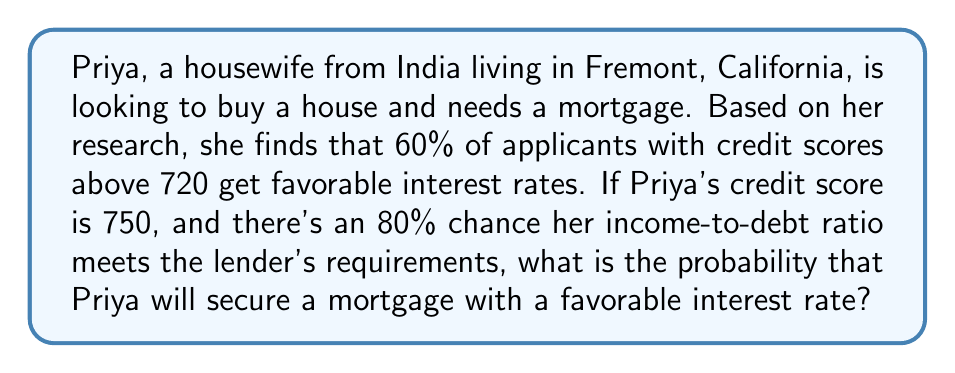Could you help me with this problem? To solve this problem, we need to consider two independent events:

1. Getting a favorable interest rate based on credit score
2. Meeting the lender's income-to-debt ratio requirements

Let's define these events:

A = Getting a favorable interest rate (60% chance given credit score > 720)
B = Meeting income-to-debt ratio requirements (80% chance)

Since Priya's credit score is 750, which is above 720, she qualifies for the 60% chance of getting a favorable rate.

To secure a mortgage with a favorable interest rate, both events A and B must occur. Since these events are independent, we can multiply their probabilities:

$$P(\text{favorable rate}) = P(A) \times P(B)$$

Substituting the given probabilities:

$$P(\text{favorable rate}) = 0.60 \times 0.80$$

$$P(\text{favorable rate}) = 0.48$$

To convert to a percentage:

$$0.48 \times 100\% = 48\%$$
Answer: The probability that Priya will secure a mortgage with a favorable interest rate is 48% or 0.48. 